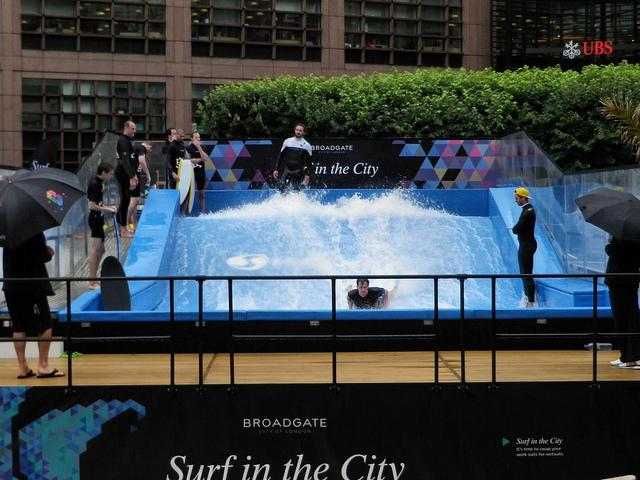What type of area is this event taking place at?

Choices:
A) rural
B) city
C) residential
D) country city 